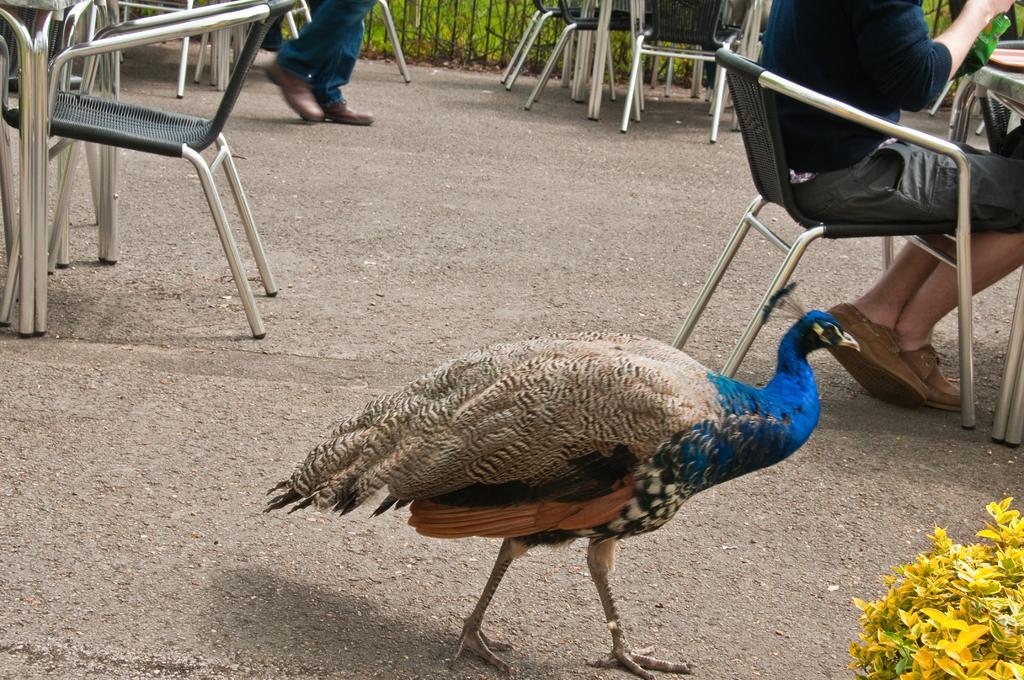Please provide a concise description of this image. In this picture we can see a peacock and a person is seated on the chair, and also we can see couple of chairs. 